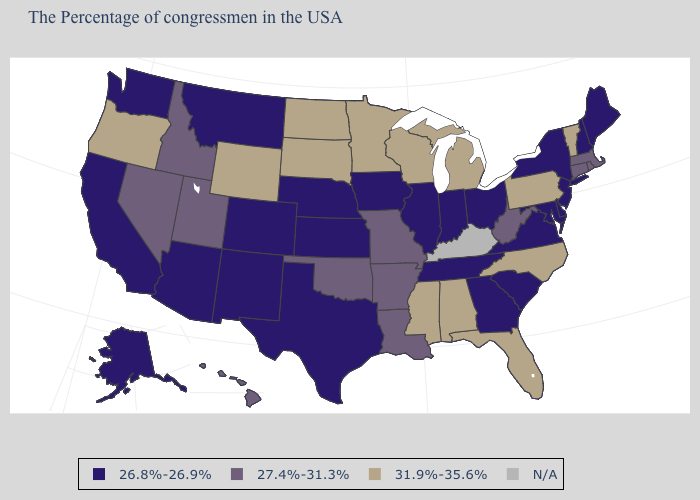Among the states that border Kentucky , does West Virginia have the highest value?
Concise answer only. Yes. Among the states that border Vermont , which have the lowest value?
Be succinct. New Hampshire, New York. What is the value of Maine?
Short answer required. 26.8%-26.9%. Does Colorado have the highest value in the USA?
Give a very brief answer. No. What is the value of New Jersey?
Be succinct. 26.8%-26.9%. What is the highest value in the USA?
Keep it brief. 31.9%-35.6%. What is the value of Oregon?
Be succinct. 31.9%-35.6%. Name the states that have a value in the range 31.9%-35.6%?
Quick response, please. Vermont, Pennsylvania, North Carolina, Florida, Michigan, Alabama, Wisconsin, Mississippi, Minnesota, South Dakota, North Dakota, Wyoming, Oregon. Among the states that border Vermont , which have the highest value?
Short answer required. Massachusetts. What is the value of Arkansas?
Quick response, please. 27.4%-31.3%. What is the value of Arizona?
Quick response, please. 26.8%-26.9%. What is the lowest value in the USA?
Short answer required. 26.8%-26.9%. Name the states that have a value in the range 26.8%-26.9%?
Answer briefly. Maine, New Hampshire, New York, New Jersey, Delaware, Maryland, Virginia, South Carolina, Ohio, Georgia, Indiana, Tennessee, Illinois, Iowa, Kansas, Nebraska, Texas, Colorado, New Mexico, Montana, Arizona, California, Washington, Alaska. Which states have the lowest value in the USA?
Keep it brief. Maine, New Hampshire, New York, New Jersey, Delaware, Maryland, Virginia, South Carolina, Ohio, Georgia, Indiana, Tennessee, Illinois, Iowa, Kansas, Nebraska, Texas, Colorado, New Mexico, Montana, Arizona, California, Washington, Alaska. 